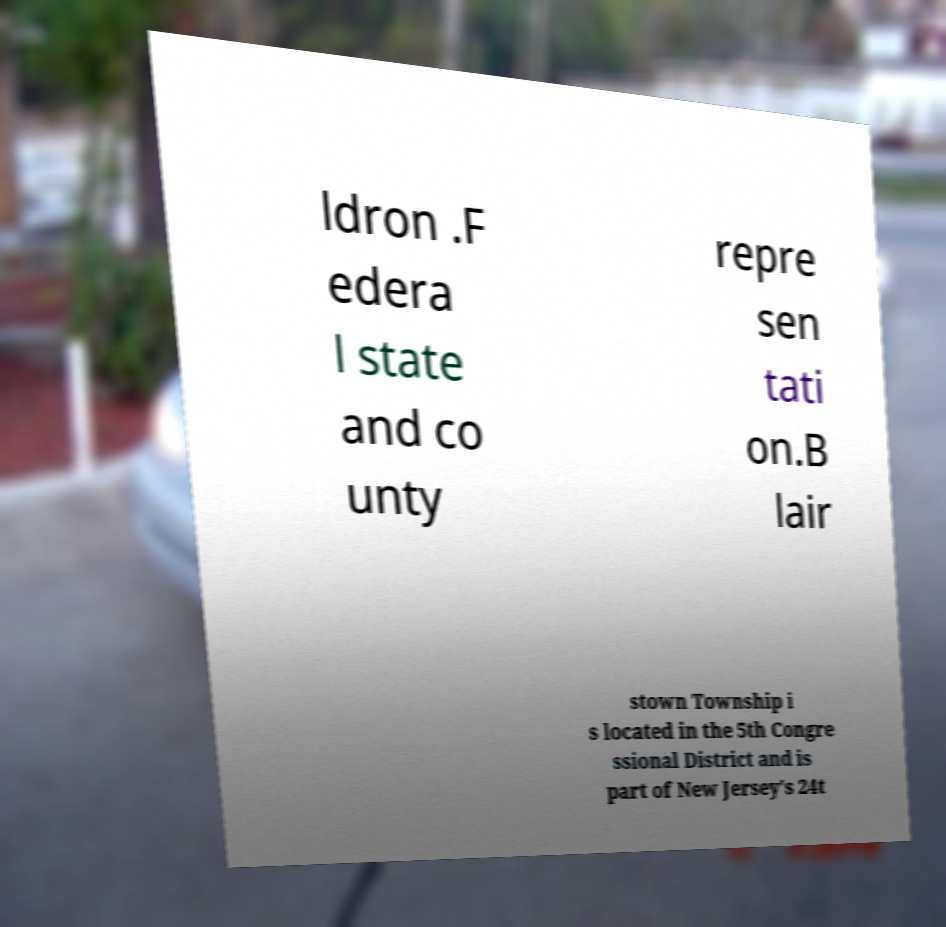I need the written content from this picture converted into text. Can you do that? ldron .F edera l state and co unty repre sen tati on.B lair stown Township i s located in the 5th Congre ssional District and is part of New Jersey's 24t 